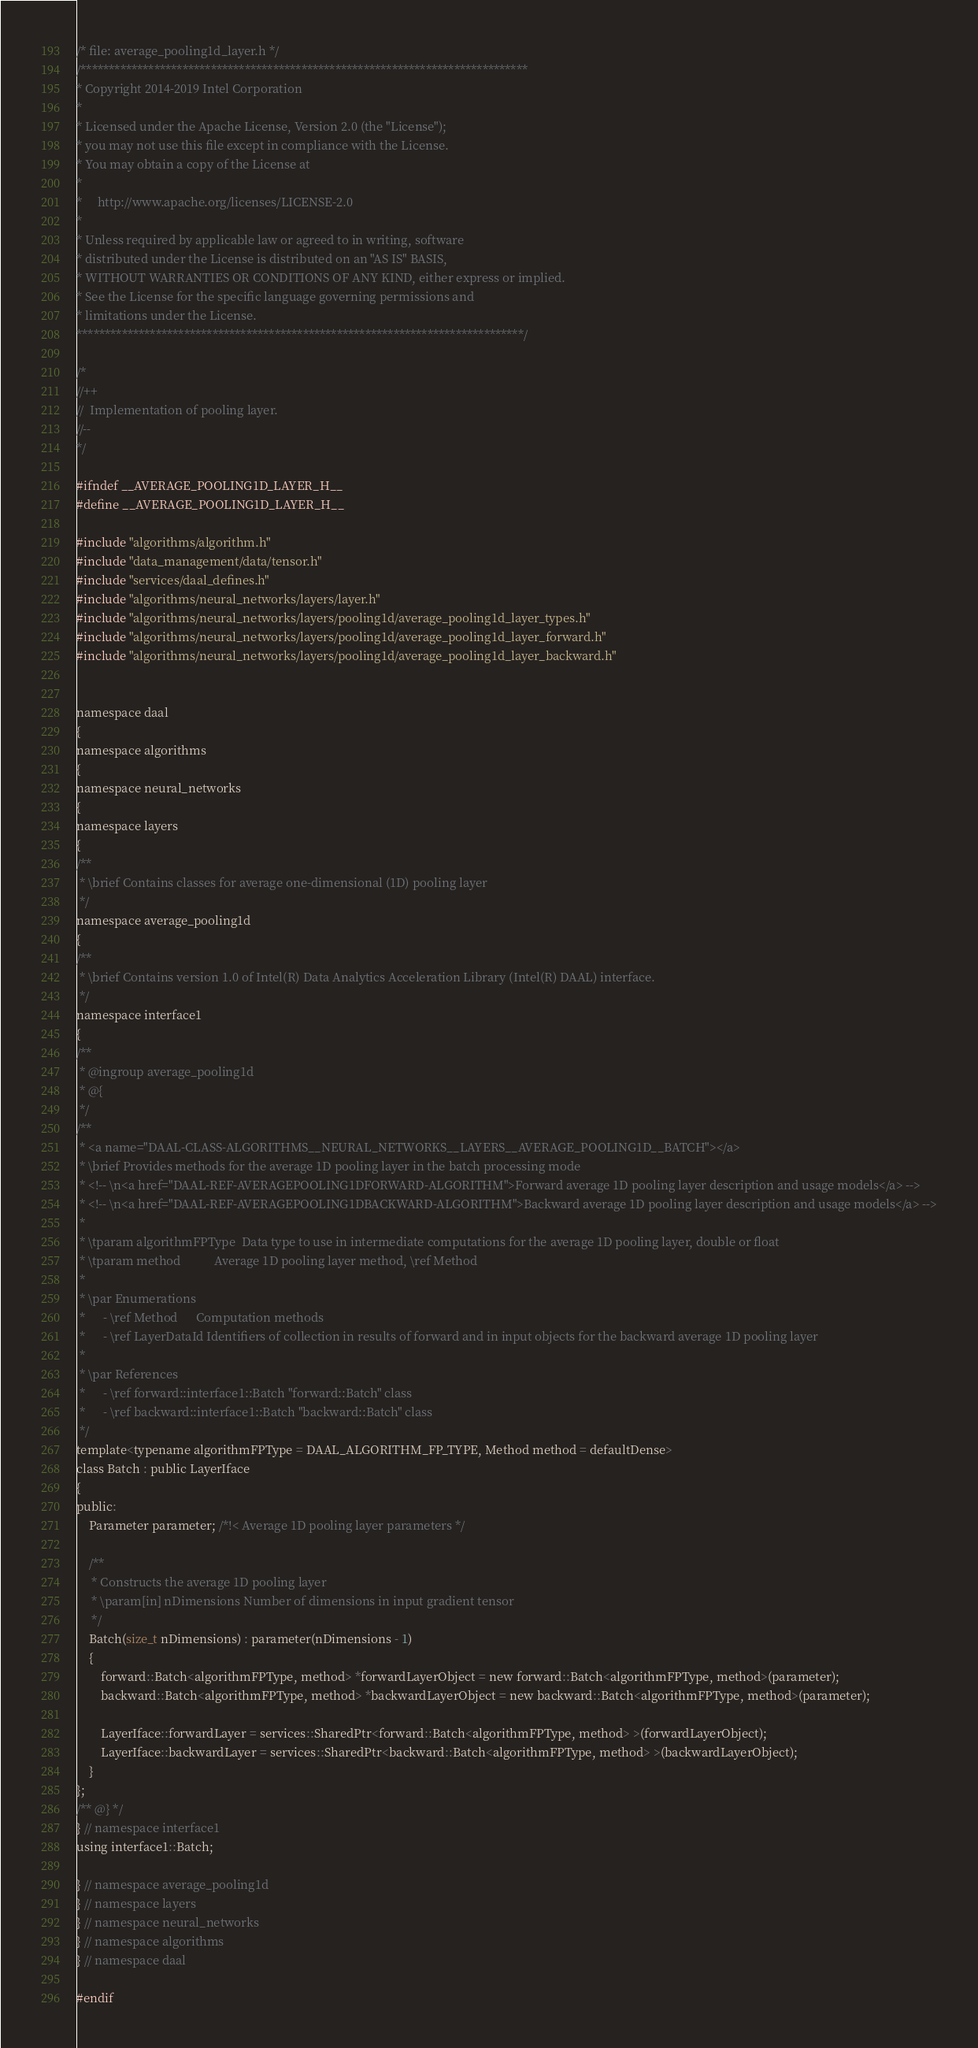Convert code to text. <code><loc_0><loc_0><loc_500><loc_500><_C_>/* file: average_pooling1d_layer.h */
/*******************************************************************************
* Copyright 2014-2019 Intel Corporation
*
* Licensed under the Apache License, Version 2.0 (the "License");
* you may not use this file except in compliance with the License.
* You may obtain a copy of the License at
*
*     http://www.apache.org/licenses/LICENSE-2.0
*
* Unless required by applicable law or agreed to in writing, software
* distributed under the License is distributed on an "AS IS" BASIS,
* WITHOUT WARRANTIES OR CONDITIONS OF ANY KIND, either express or implied.
* See the License for the specific language governing permissions and
* limitations under the License.
*******************************************************************************/

/*
//++
//  Implementation of pooling layer.
//--
*/

#ifndef __AVERAGE_POOLING1D_LAYER_H__
#define __AVERAGE_POOLING1D_LAYER_H__

#include "algorithms/algorithm.h"
#include "data_management/data/tensor.h"
#include "services/daal_defines.h"
#include "algorithms/neural_networks/layers/layer.h"
#include "algorithms/neural_networks/layers/pooling1d/average_pooling1d_layer_types.h"
#include "algorithms/neural_networks/layers/pooling1d/average_pooling1d_layer_forward.h"
#include "algorithms/neural_networks/layers/pooling1d/average_pooling1d_layer_backward.h"


namespace daal
{
namespace algorithms
{
namespace neural_networks
{
namespace layers
{
/**
 * \brief Contains classes for average one-dimensional (1D) pooling layer
 */
namespace average_pooling1d
{
/**
 * \brief Contains version 1.0 of Intel(R) Data Analytics Acceleration Library (Intel(R) DAAL) interface.
 */
namespace interface1
{
/**
 * @ingroup average_pooling1d
 * @{
 */
/**
 * <a name="DAAL-CLASS-ALGORITHMS__NEURAL_NETWORKS__LAYERS__AVERAGE_POOLING1D__BATCH"></a>
 * \brief Provides methods for the average 1D pooling layer in the batch processing mode
 * <!-- \n<a href="DAAL-REF-AVERAGEPOOLING1DFORWARD-ALGORITHM">Forward average 1D pooling layer description and usage models</a> -->
 * <!-- \n<a href="DAAL-REF-AVERAGEPOOLING1DBACKWARD-ALGORITHM">Backward average 1D pooling layer description and usage models</a> -->
 *
 * \tparam algorithmFPType  Data type to use in intermediate computations for the average 1D pooling layer, double or float
 * \tparam method           Average 1D pooling layer method, \ref Method
 *
 * \par Enumerations
 *      - \ref Method      Computation methods
 *      - \ref LayerDataId Identifiers of collection in results of forward and in input objects for the backward average 1D pooling layer
 *
 * \par References
 *      - \ref forward::interface1::Batch "forward::Batch" class
 *      - \ref backward::interface1::Batch "backward::Batch" class
 */
template<typename algorithmFPType = DAAL_ALGORITHM_FP_TYPE, Method method = defaultDense>
class Batch : public LayerIface
{
public:
    Parameter parameter; /*!< Average 1D pooling layer parameters */

    /**
     * Constructs the average 1D pooling layer
     * \param[in] nDimensions Number of dimensions in input gradient tensor
     */
    Batch(size_t nDimensions) : parameter(nDimensions - 1)
    {
        forward::Batch<algorithmFPType, method> *forwardLayerObject = new forward::Batch<algorithmFPType, method>(parameter);
        backward::Batch<algorithmFPType, method> *backwardLayerObject = new backward::Batch<algorithmFPType, method>(parameter);

        LayerIface::forwardLayer = services::SharedPtr<forward::Batch<algorithmFPType, method> >(forwardLayerObject);
        LayerIface::backwardLayer = services::SharedPtr<backward::Batch<algorithmFPType, method> >(backwardLayerObject);
    }
};
/** @} */
} // namespace interface1
using interface1::Batch;

} // namespace average_pooling1d
} // namespace layers
} // namespace neural_networks
} // namespace algorithms
} // namespace daal

#endif
</code> 